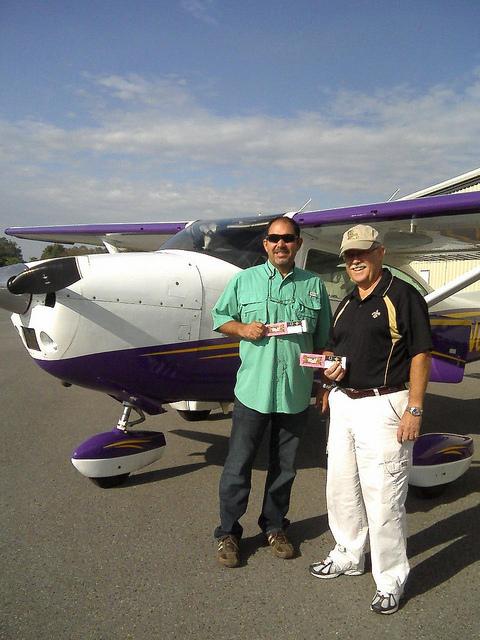What color is the plane?
Short answer required. White. Are the men related?
Short answer required. No. Do either of the men have on a purple shirt?
Concise answer only. No. 